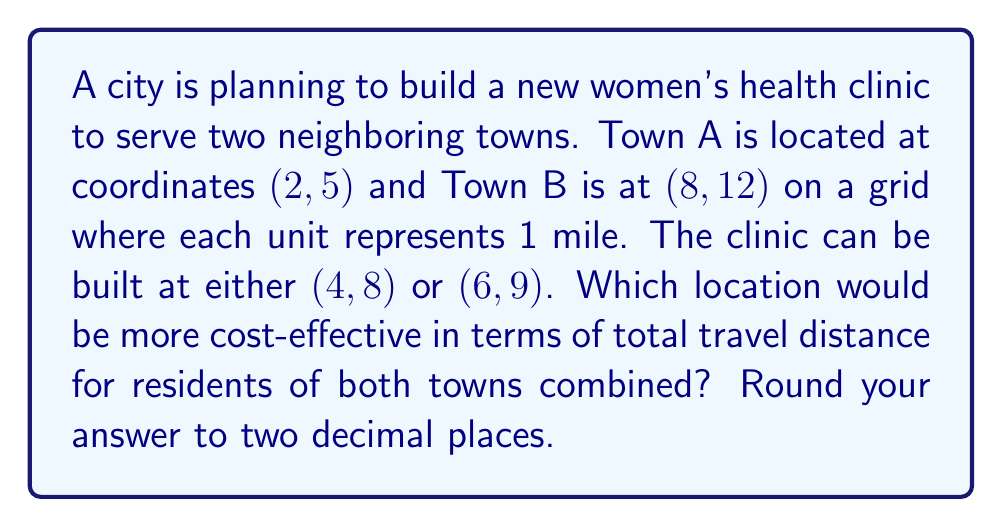What is the answer to this math problem? To solve this problem, we'll use the distance formula to calculate the distances from each town to both potential clinic locations. Then, we'll sum the distances for each option to determine which is more cost-effective.

The distance formula is:
$$d = \sqrt{(x_2 - x_1)^2 + (y_2 - y_1)^2}$$

1. Calculate distances for clinic at (4, 8):

   For Town A (2, 5):
   $$d_A = \sqrt{(4 - 2)^2 + (8 - 5)^2} = \sqrt{4 + 9} = \sqrt{13} \approx 3.61 \text{ miles}$$

   For Town B (8, 12):
   $$d_B = \sqrt{(4 - 8)^2 + (8 - 12)^2} = \sqrt{16 + 16} = \sqrt{32} \approx 5.66 \text{ miles}$$

   Total distance: $3.61 + 5.66 = 9.27 \text{ miles}$

2. Calculate distances for clinic at (6, 9):

   For Town A (2, 5):
   $$d_A = \sqrt{(6 - 2)^2 + (9 - 5)^2} = \sqrt{16 + 16} = \sqrt{32} \approx 5.66 \text{ miles}$$

   For Town B (8, 12):
   $$d_B = \sqrt{(6 - 8)^2 + (9 - 12)^2} = \sqrt{4 + 9} = \sqrt{13} \approx 3.61 \text{ miles}$$

   Total distance: $5.66 + 3.61 = 9.27 \text{ miles}$

3. Compare the total distances:
   Both locations result in the same total travel distance of 9.27 miles.
Answer: Both locations are equally cost-effective 